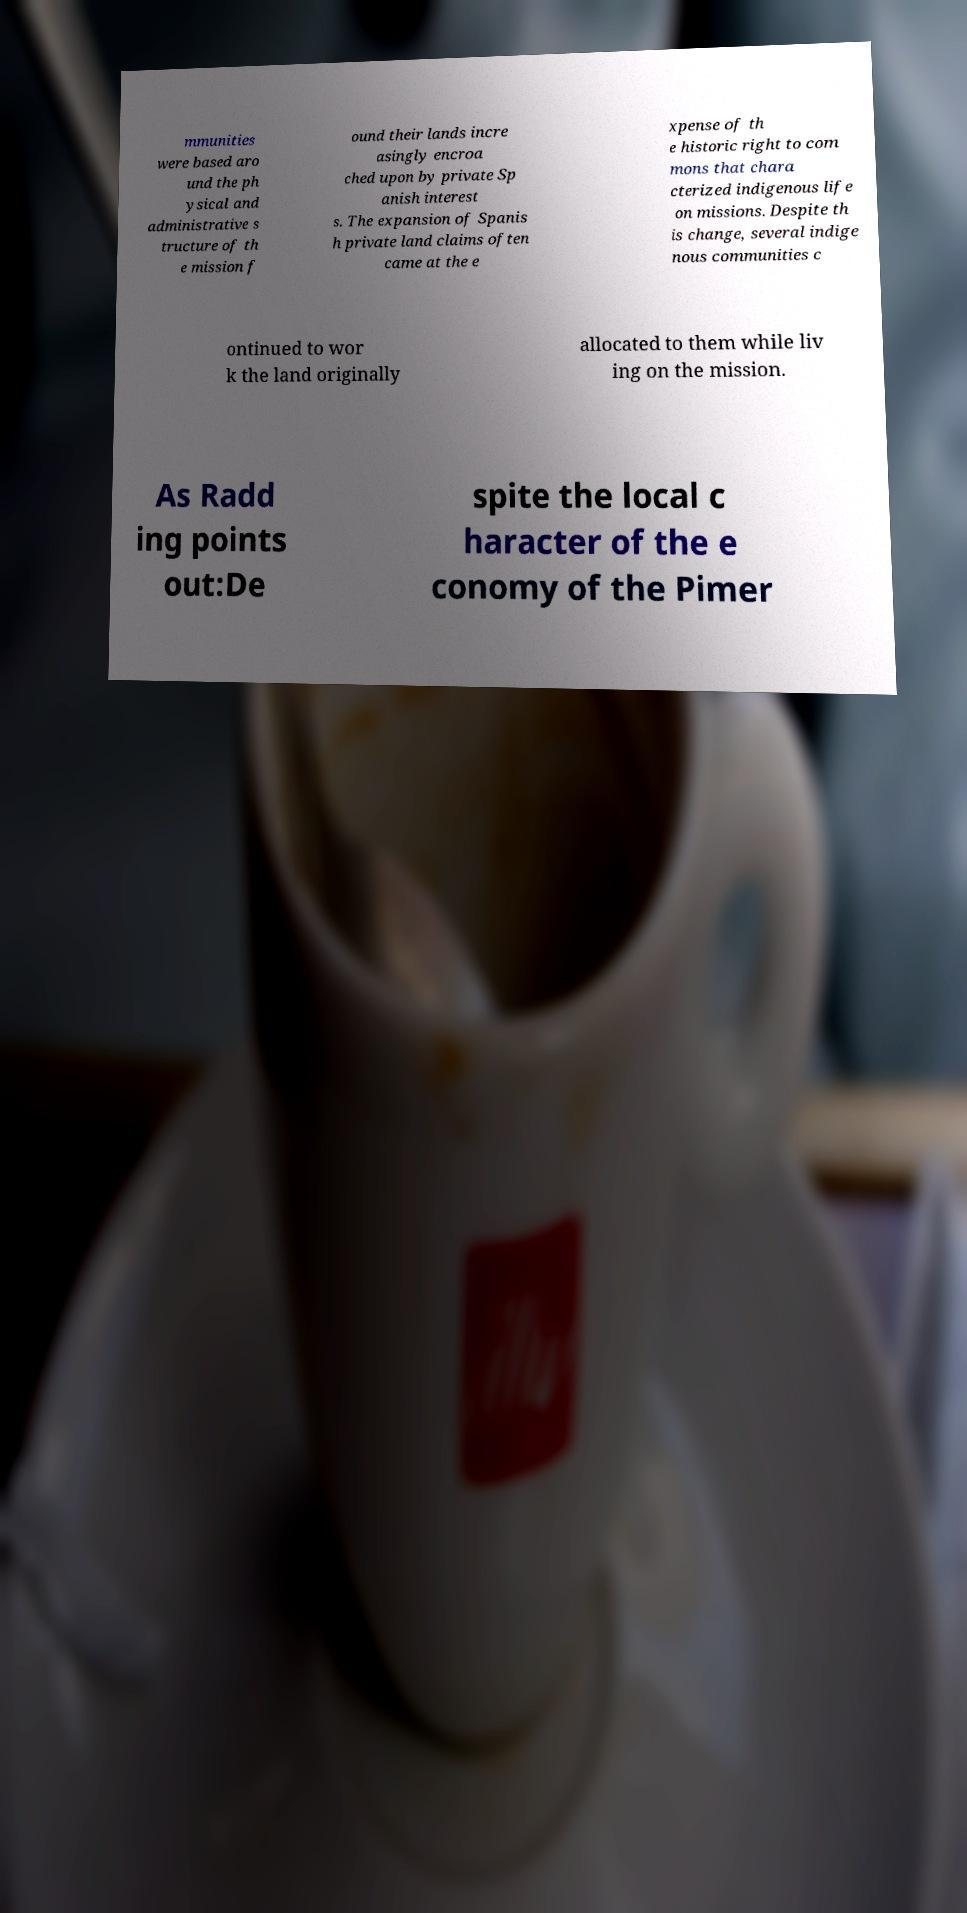Please identify and transcribe the text found in this image. mmunities were based aro und the ph ysical and administrative s tructure of th e mission f ound their lands incre asingly encroa ched upon by private Sp anish interest s. The expansion of Spanis h private land claims often came at the e xpense of th e historic right to com mons that chara cterized indigenous life on missions. Despite th is change, several indige nous communities c ontinued to wor k the land originally allocated to them while liv ing on the mission. As Radd ing points out:De spite the local c haracter of the e conomy of the Pimer 